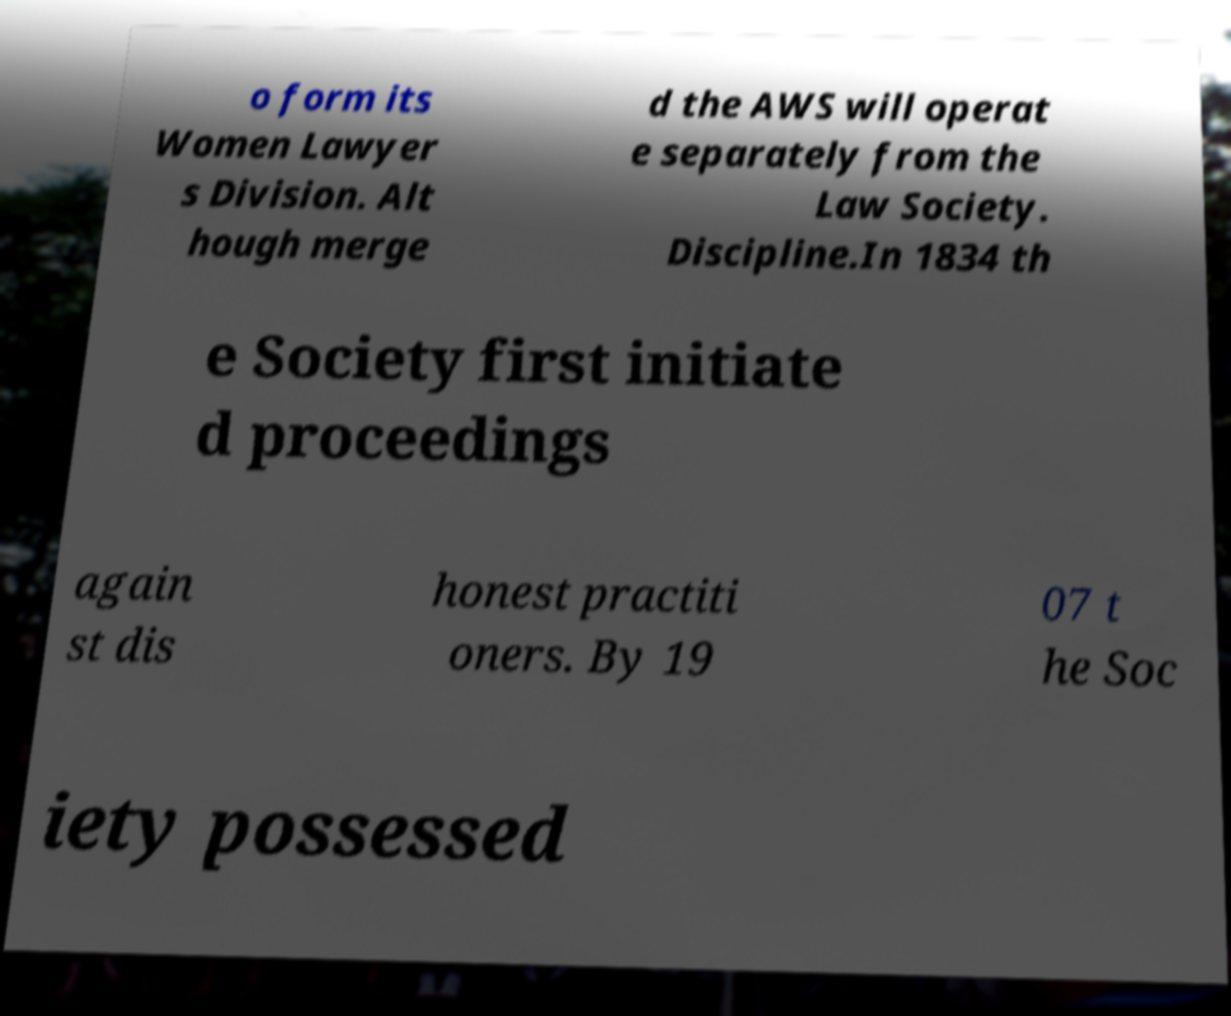Can you read and provide the text displayed in the image?This photo seems to have some interesting text. Can you extract and type it out for me? o form its Women Lawyer s Division. Alt hough merge d the AWS will operat e separately from the Law Society. Discipline.In 1834 th e Society first initiate d proceedings again st dis honest practiti oners. By 19 07 t he Soc iety possessed 